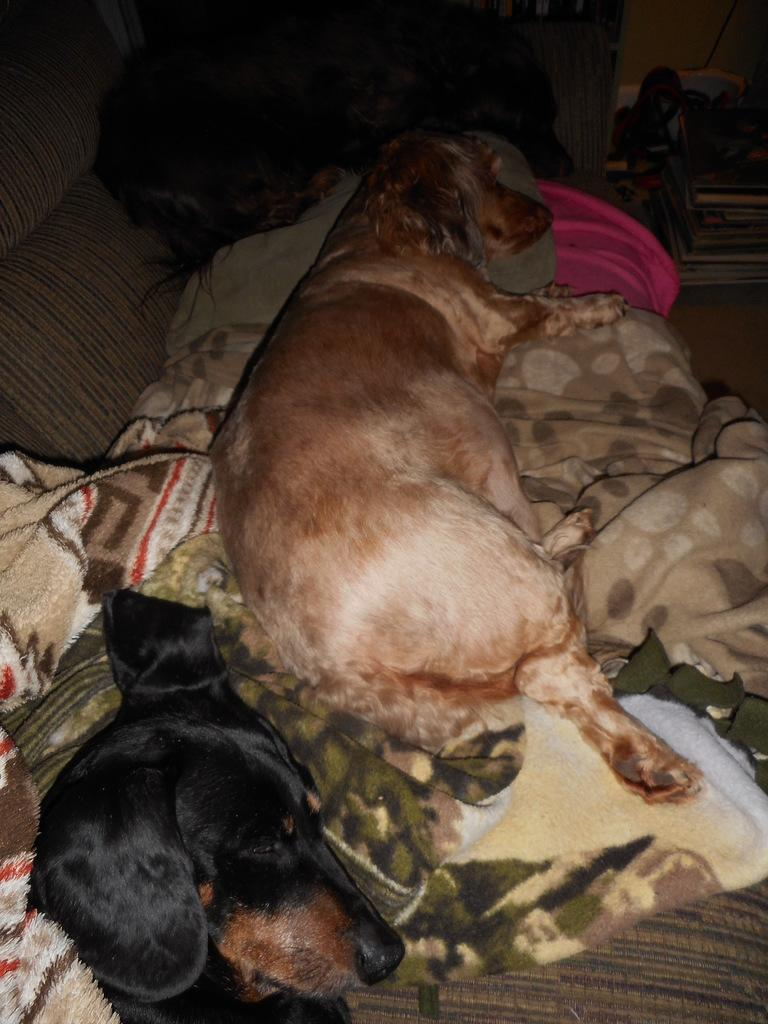What type of animals are present in the image? There are dogs in the image. What are the dogs doing in the image? The dogs are sleeping. Is there any object in the image that might be used for warmth or comfort? Yes, there is a blanket in the image. What type of apparatus is being used by the bee in the image? There is no bee present in the image, so there is no apparatus being used by a bee. 